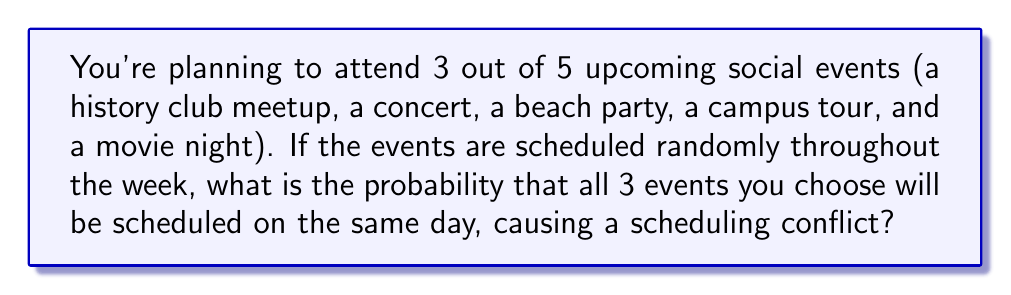Give your solution to this math problem. Let's approach this step-by-step:

1) First, we need to calculate the total number of ways to choose 3 events out of 5. This is a combination problem:

   $$\binom{5}{3} = \frac{5!}{3!(5-3)!} = \frac{5 \cdot 4 \cdot 3}{3 \cdot 2 \cdot 1} = 10$$

2) Now, for the favorable outcomes, we need all 3 chosen events to be on the same day. There are 7 days in a week, so the probability of all 3 events being on the same day is:

   $$\frac{1}{7} \cdot \frac{1}{7} \cdot \frac{1}{7} = \frac{1}{343}$$

3) However, this is just for one specific combination of 3 events. We need to consider all 10 possible combinations.

4) The probability for each combination is the same $\frac{1}{343}$, and these are mutually exclusive events (it's impossible for two different combinations of 3 events to all be on the same day).

5) Therefore, we can add the probabilities for each of the 10 combinations:

   $$10 \cdot \frac{1}{343} = \frac{10}{343}$$

This is our final probability.
Answer: $\frac{10}{343}$ 